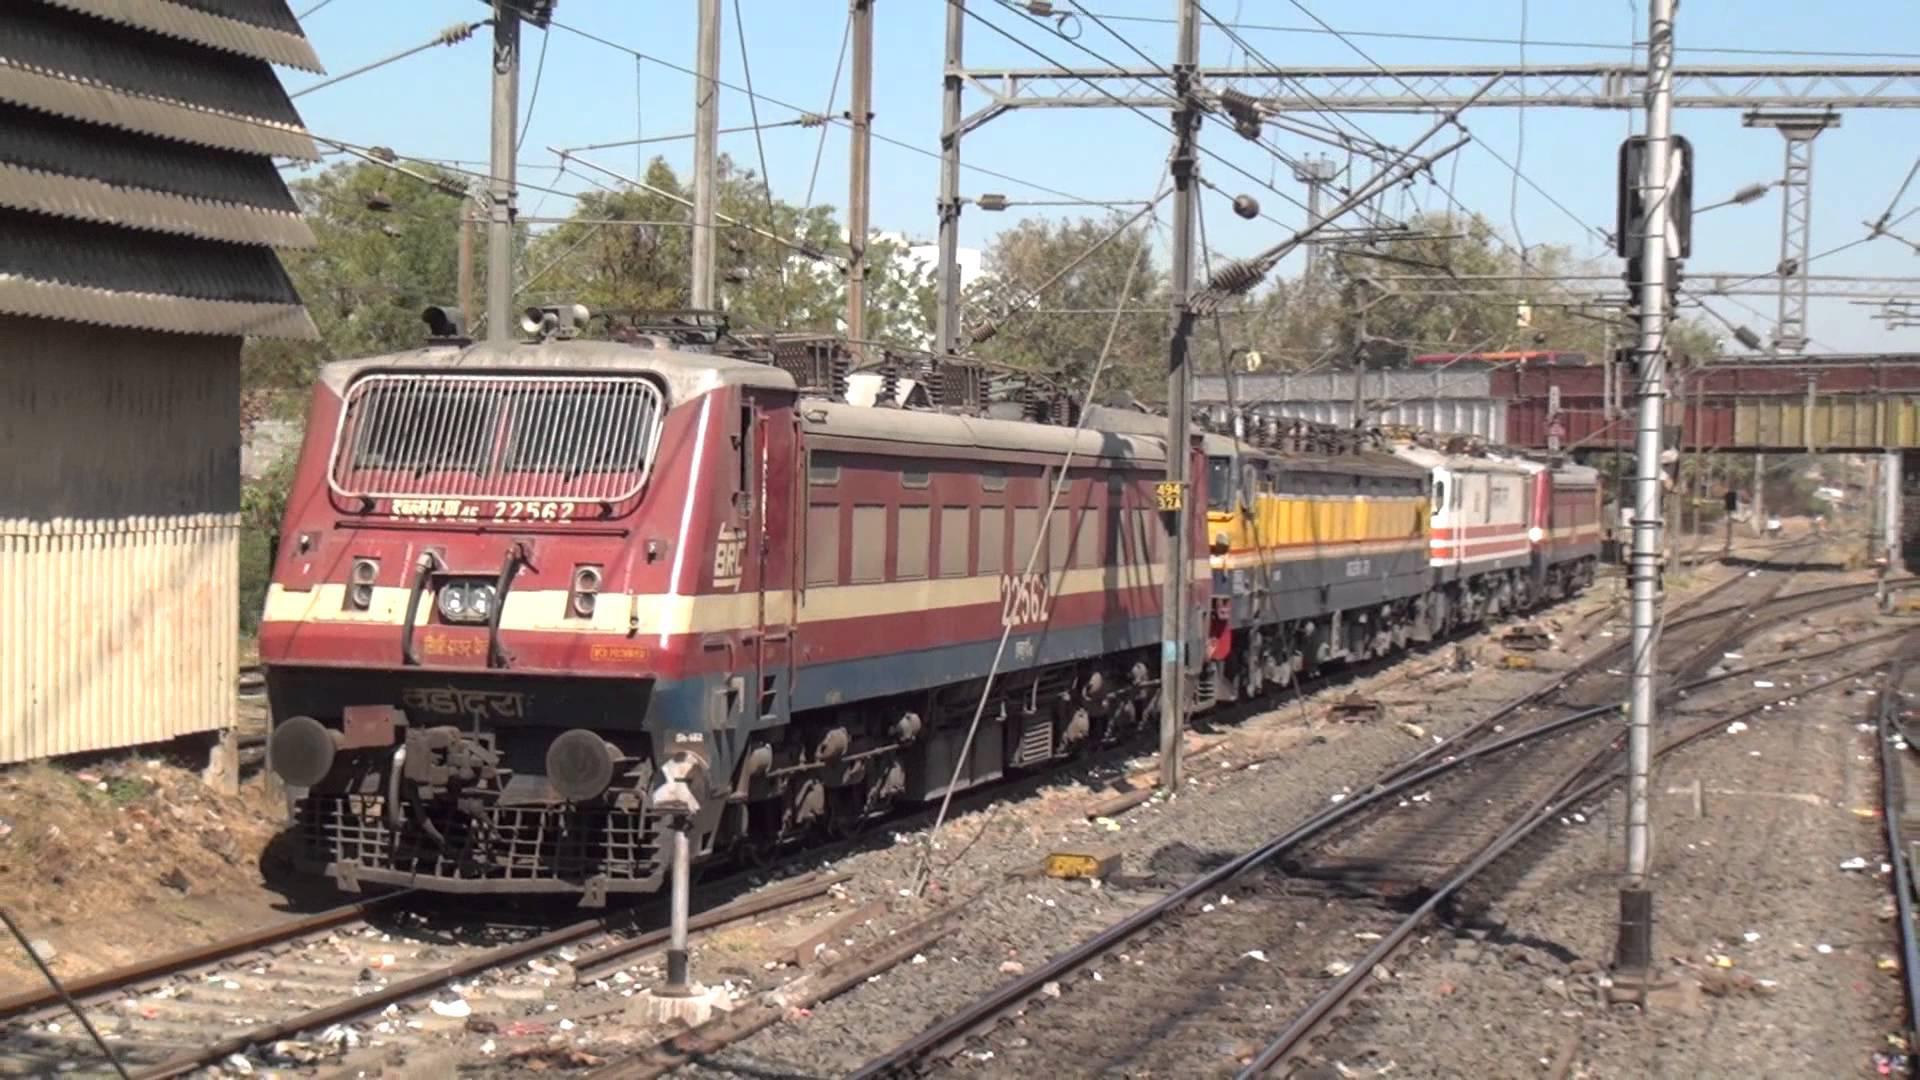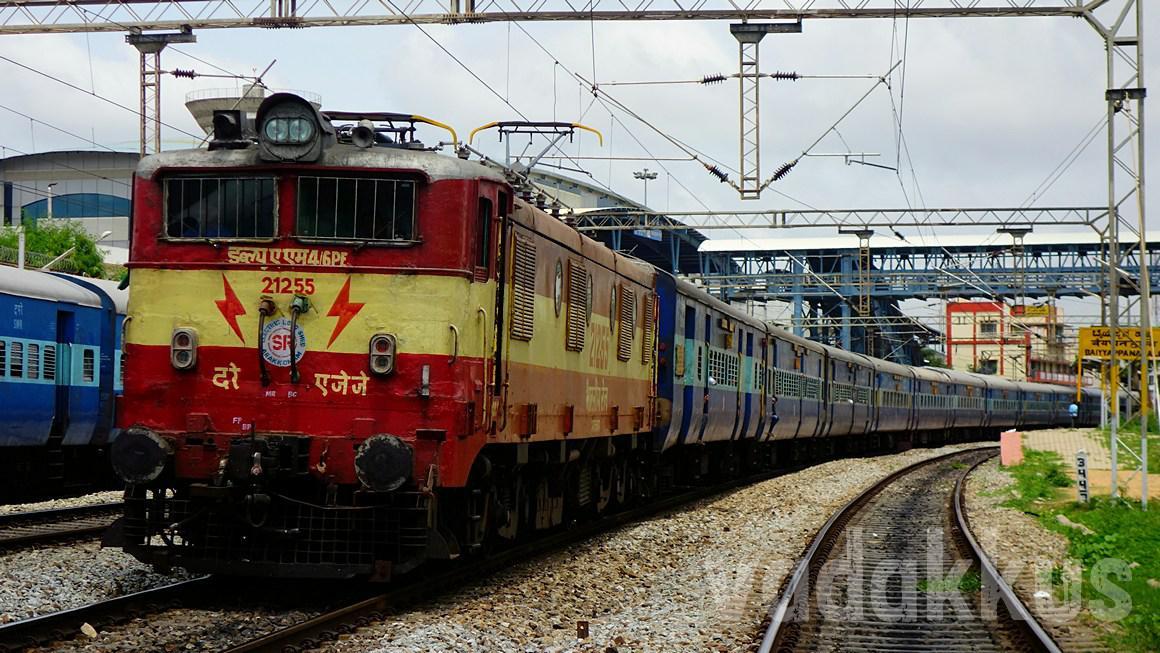The first image is the image on the left, the second image is the image on the right. Analyze the images presented: Is the assertion "There is a white stripe all the way around the bottom of the train in the image on the right." valid? Answer yes or no. No. 